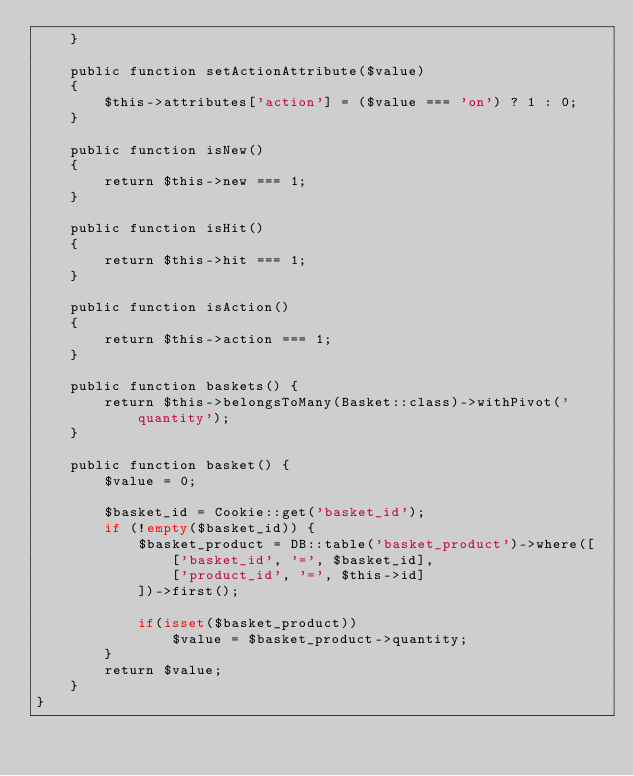<code> <loc_0><loc_0><loc_500><loc_500><_PHP_>    }

    public function setActionAttribute($value)
    {
        $this->attributes['action'] = ($value === 'on') ? 1 : 0;
    }

    public function isNew()
    {
        return $this->new === 1;
    }

    public function isHit()
    {
        return $this->hit === 1;
    }

    public function isAction()
    {
        return $this->action === 1;
    }

    public function baskets() {
        return $this->belongsToMany(Basket::class)->withPivot('quantity');
    }

    public function basket() {
        $value = 0;

        $basket_id = Cookie::get('basket_id');
        if (!empty($basket_id)) {
            $basket_product = DB::table('basket_product')->where([
                ['basket_id', '=', $basket_id],
                ['product_id', '=', $this->id]
            ])->first();

            if(isset($basket_product))
                $value = $basket_product->quantity;
        }
        return $value;
    }
}
</code> 